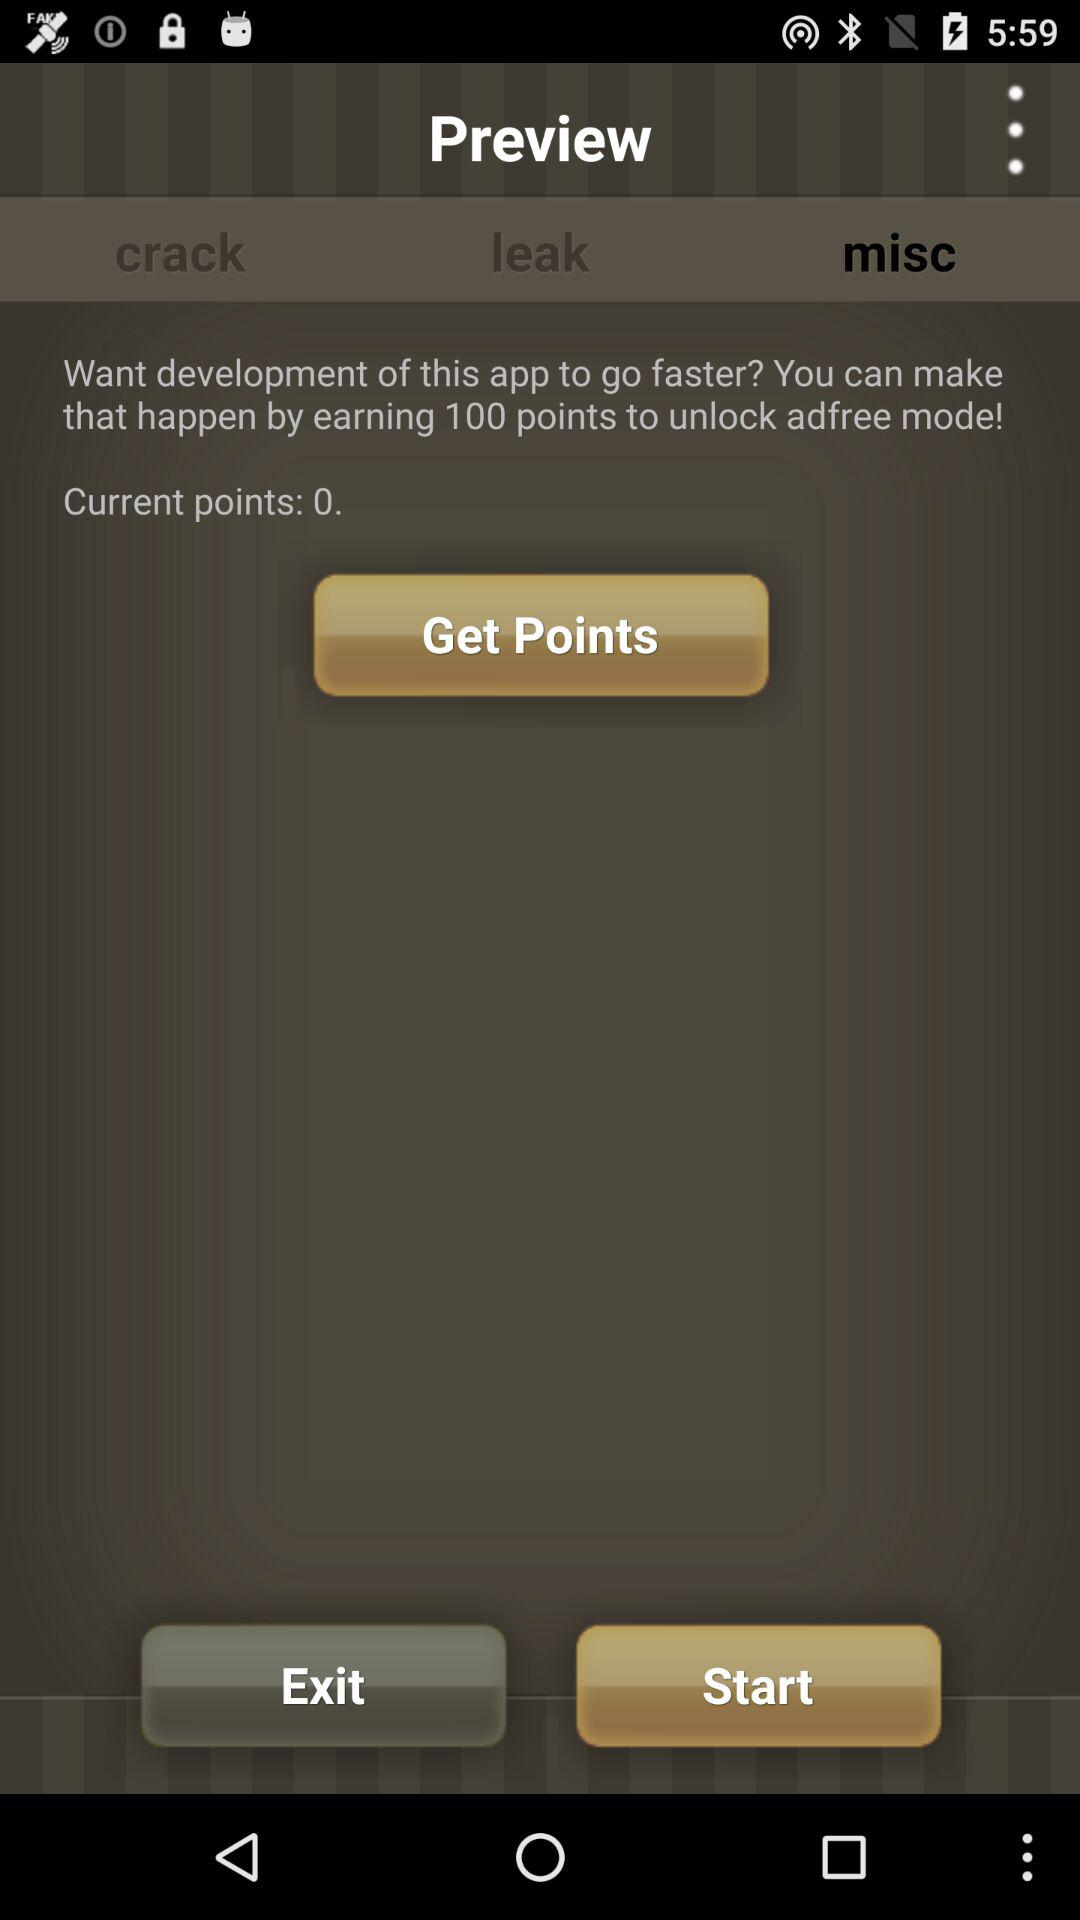How many points are required to unlock ad-free mode? It requires 100 points to unlock ad-free mode. 